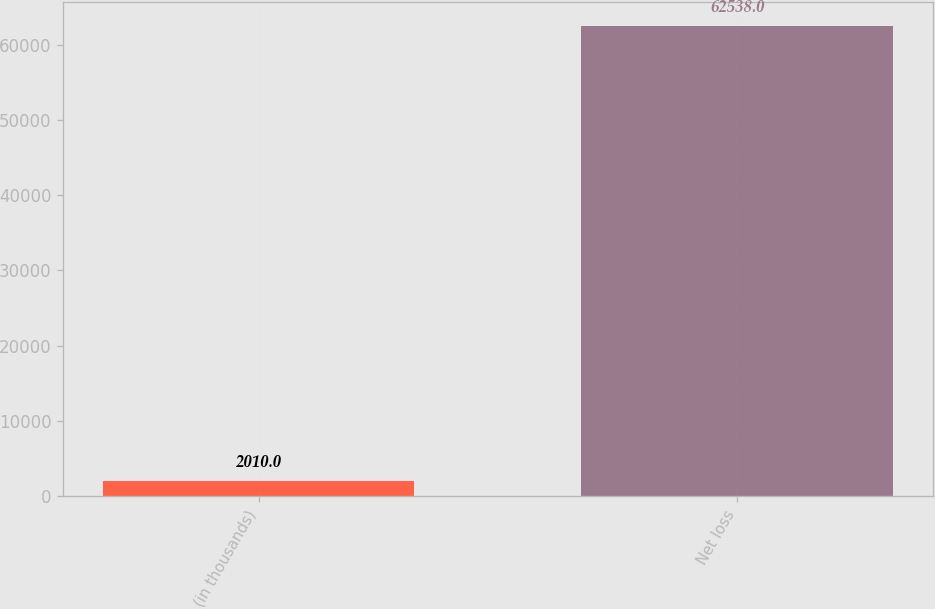<chart> <loc_0><loc_0><loc_500><loc_500><bar_chart><fcel>(in thousands)<fcel>Net loss<nl><fcel>2010<fcel>62538<nl></chart> 